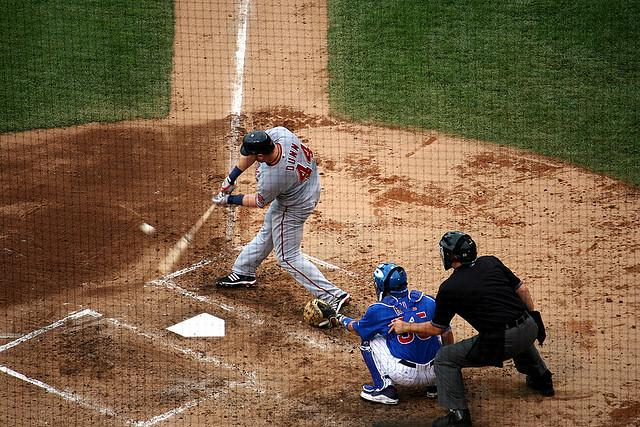What is number 44 doing? swinging bat 